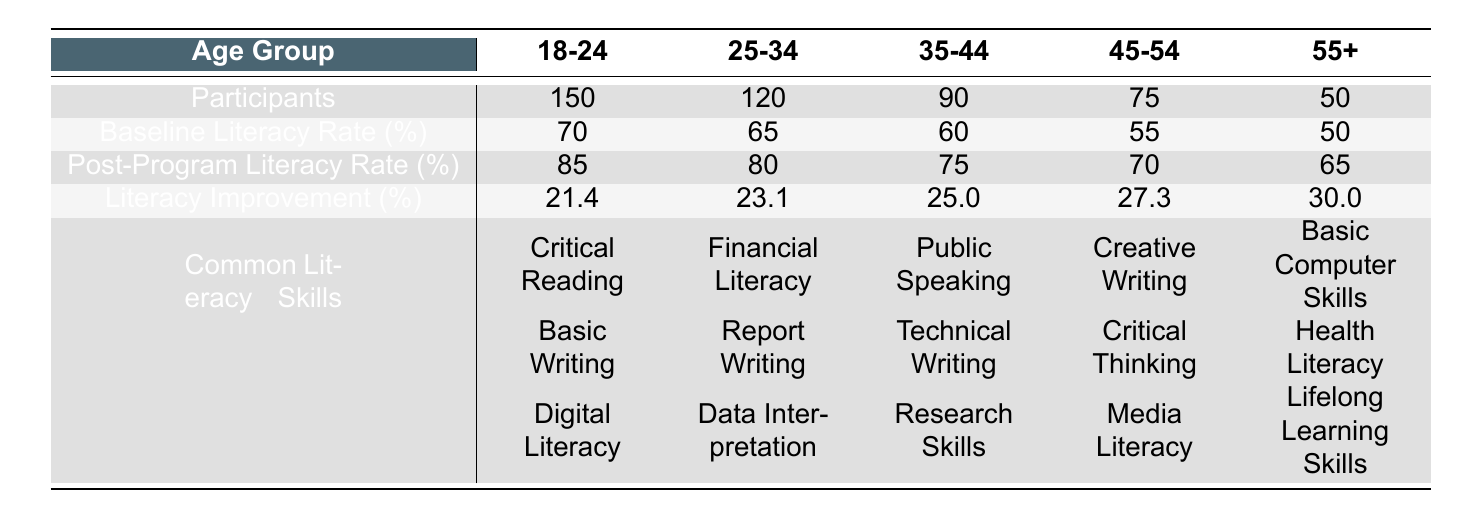What is the baseline literacy rate for the age group 45-54? The baseline literacy rate for the age group 45-54 is directly listed in the table under the "Baseline Literacy Rate (%)" row for that age group, which shows 55%.
Answer: 55 How many participants were there in the age group 25-34? The number of participants in the age group 25-34 is found in the "Participants" row directly corresponding to that age group, which is 120.
Answer: 120 What age group had the highest percentage of literacy improvement? By comparing the "Literacy Improvement (%)" values for each age group, the 55+ age group shows the highest percentage at 30%.
Answer: 55+ What is the difference between the baseline literacy rate of the age groups 18-24 and 35-44? The baseline literacy rate for age group 18-24 is 70% and for age group 35-44 it is 60%. The difference is calculated as 70 - 60 = 10.
Answer: 10 Did the age group 55+ develop skills in Digital Literacy? Looking at the "Common Literacy Skills Developed" section for the 55+ age group, the skills listed do not include Digital Literacy, which means the answer is no.
Answer: No What is the average post-program literacy rate across all age groups? To find the average post-program literacy rate, sum the post-program rates: 85 + 80 + 75 + 70 + 65 = 375. Then divide by the number of age groups, which is 5. Thus, the average is 375 / 5 = 75.
Answer: 75 Which age group showed the least improvement in literacy? Comparing the "Literacy Improvement (%)" across all groups, the age group 18-24 shows the least improvement of 21.4%.
Answer: 18-24 If a new program increased literacy by an additional 5% for the 35-44 age group, what would the new post-program literacy rate be? The current post-program literacy rate for the 35-44 age group is 75%. Adding 5% would result in 75 + 5 = 80%.
Answer: 80 How many total participants were involved across all age groups? To find the total participants, sum up all participants: 150 + 120 + 90 + 75 + 50 = 485.
Answer: 485 